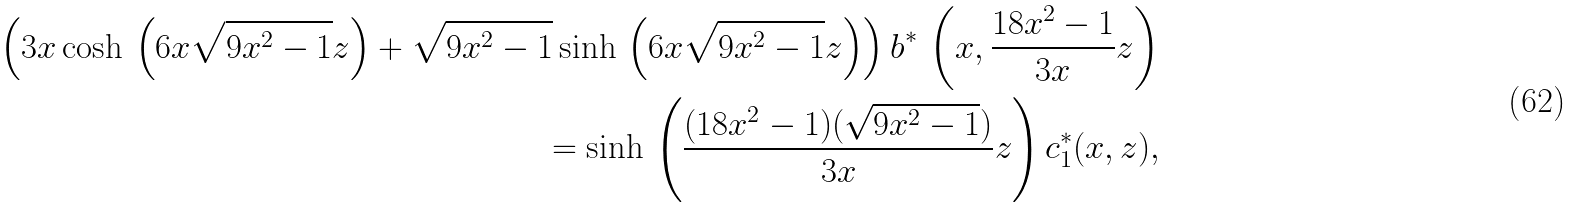<formula> <loc_0><loc_0><loc_500><loc_500>\left ( 3 x \cosh \, \left ( 6 x \sqrt { 9 x ^ { 2 } - 1 } z \right ) + \sqrt { 9 x ^ { 2 } - 1 } \sinh \, \left ( 6 x \sqrt { 9 x ^ { 2 } - 1 } z \right ) \right ) b ^ { * } \, \left ( x , \frac { 1 8 x ^ { 2 } - 1 } { 3 x } z \right ) \\ = \sinh \, \left ( \frac { ( 1 8 x ^ { 2 } - 1 ) ( \sqrt { 9 x ^ { 2 } - 1 } ) } { 3 x } z \right ) c _ { 1 } ^ { * } ( x , z ) ,</formula> 